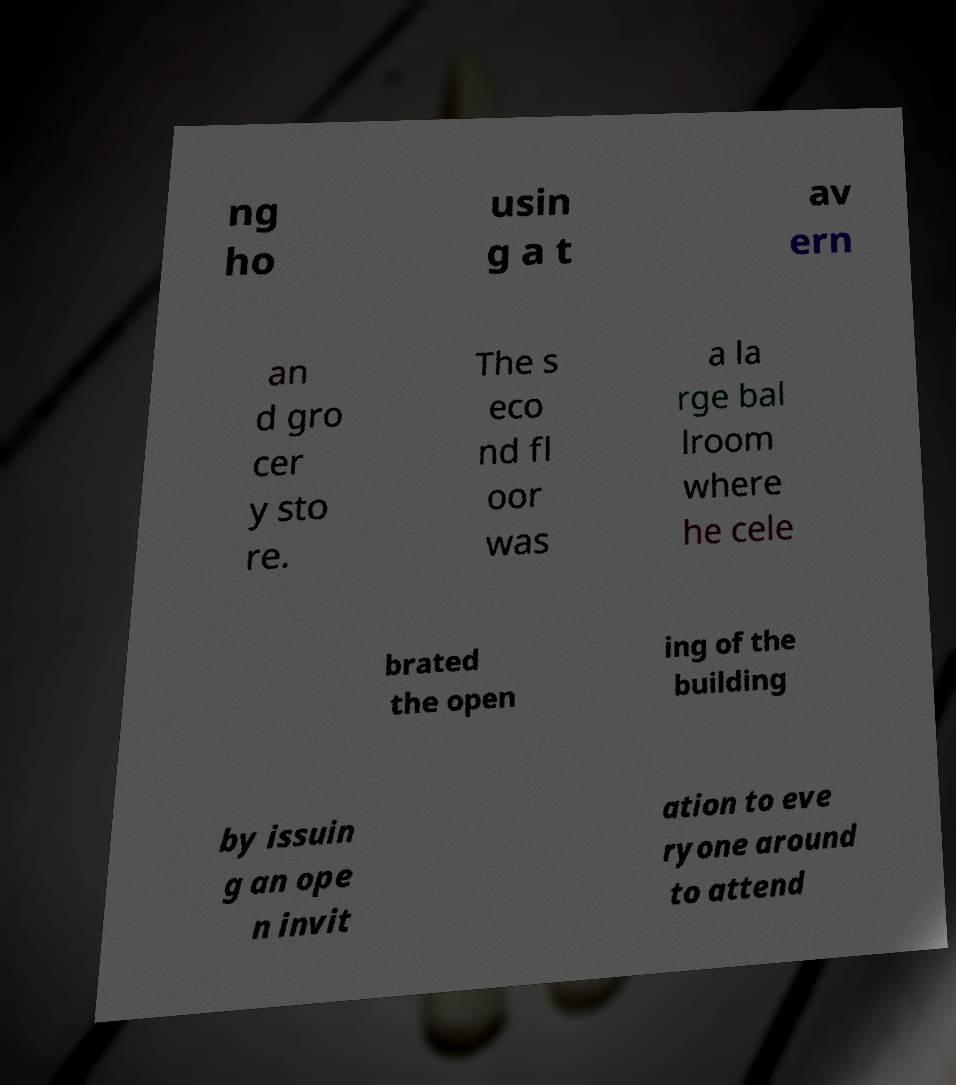I need the written content from this picture converted into text. Can you do that? ng ho usin g a t av ern an d gro cer y sto re. The s eco nd fl oor was a la rge bal lroom where he cele brated the open ing of the building by issuin g an ope n invit ation to eve ryone around to attend 